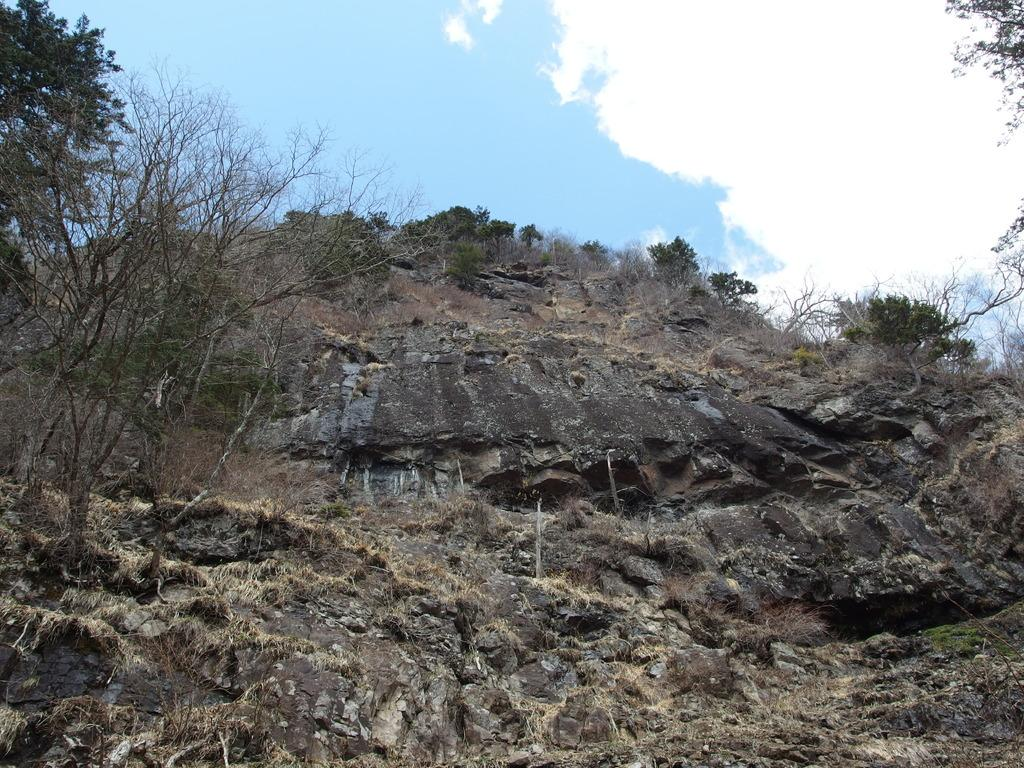What type of natural features can be seen on the hill in the image? There are trees and plants on the hill in the image. What is the main geographical feature visible in the image? There is a hill visible in the image. What type of objects are present on the hill? There are stones on the hill. What can be seen in the background of the image? The sky is visible in the background of the image. What is the weather like in the image? The presence of clouds in the sky suggests that it might be partly cloudy. What type of arch can be seen in the image? There is no arch present in the image. What type of battle is taking place on the hill in the image? There is no battle present in the image; it features a hill with trees, plants, and stones. What type of cooking equipment can be seen on the hill in the image? There is no cooking equipment present in the image. 